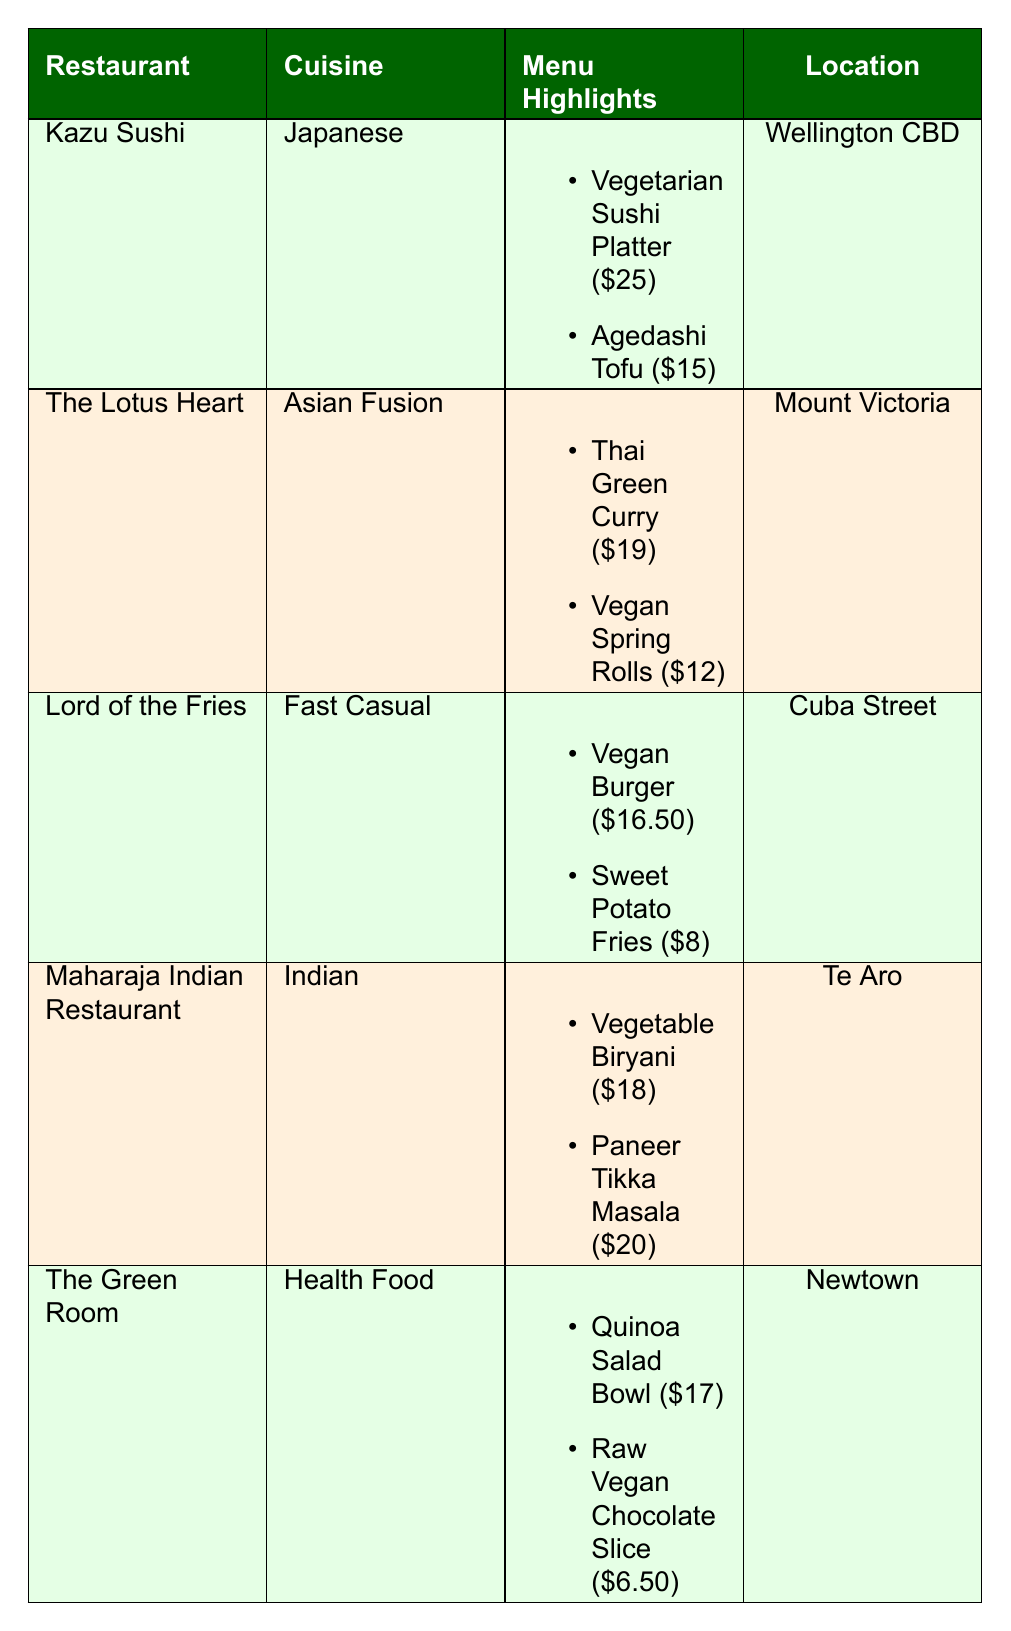What are the two menu highlights of Kazu Sushi? The table lists Kazu Sushi's menu highlights. They are the Vegetarian Sushi Platter priced at $25 and Agedashi Tofu priced at $15.
Answer: Vegetarian Sushi Platter and Agedashi Tofu Which restaurant is located in Cuba Street? By examining the location column, Lord of the Fries is identified as being located in Cuba Street.
Answer: Lord of the Fries Is The Green Room's menu vegan? The Green Room emphasizes organic produce and compostable materials, but it does not explicitly state that the entire menu is vegan, as it includes a Raw Vegan Chocolate Slice, which indicates some items are vegan. However, it is not clearly stated.
Answer: No What is the average price of an item from The Lotus Heart? The menu items from The Lotus Heart are the Thai Green Curry at $19 and Vegan Spring Rolls at $12. The average is calculated by summing these two prices (19 + 12 = 31) and dividing by the number of items (31 / 2 = 15.50).
Answer: 15.50 Which restaurant has a zero waste philosophy? The eco-friendly status of Lord of the Fries states that it follows a 100% vegan and zero waste philosophy.
Answer: Lord of the Fries What is the total price of the menu highlights from Maharaja Indian Restaurant? The menu highlights include Vegetable Biryani for $18 and Paneer Tikka Masala for $20. The total is calculated as (18 + 20) = 38.
Answer: 38 Does the restaurant Kazu Sushi source its ingredients organically? The eco-friendly status listed for Kazu Sushi states that it uses organic ingredients sourced locally, confirming that it does.
Answer: Yes Which dish is the least expensive on the menu of The Green Room? Among the menu items, the Raw Vegan Chocolate Slice is priced at $6.50, making it the least expensive compared to the Quinoa Salad Bowl at $17.
Answer: Raw Vegan Chocolate Slice 